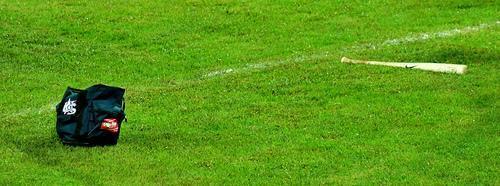How many logos are on the bag?
Give a very brief answer. 2. How many items are in the photo?
Give a very brief answer. 2. How many bags are there?
Give a very brief answer. 1. How many bats are in the scene?
Give a very brief answer. 1. How many white lines are on the grass?
Give a very brief answer. 1. 